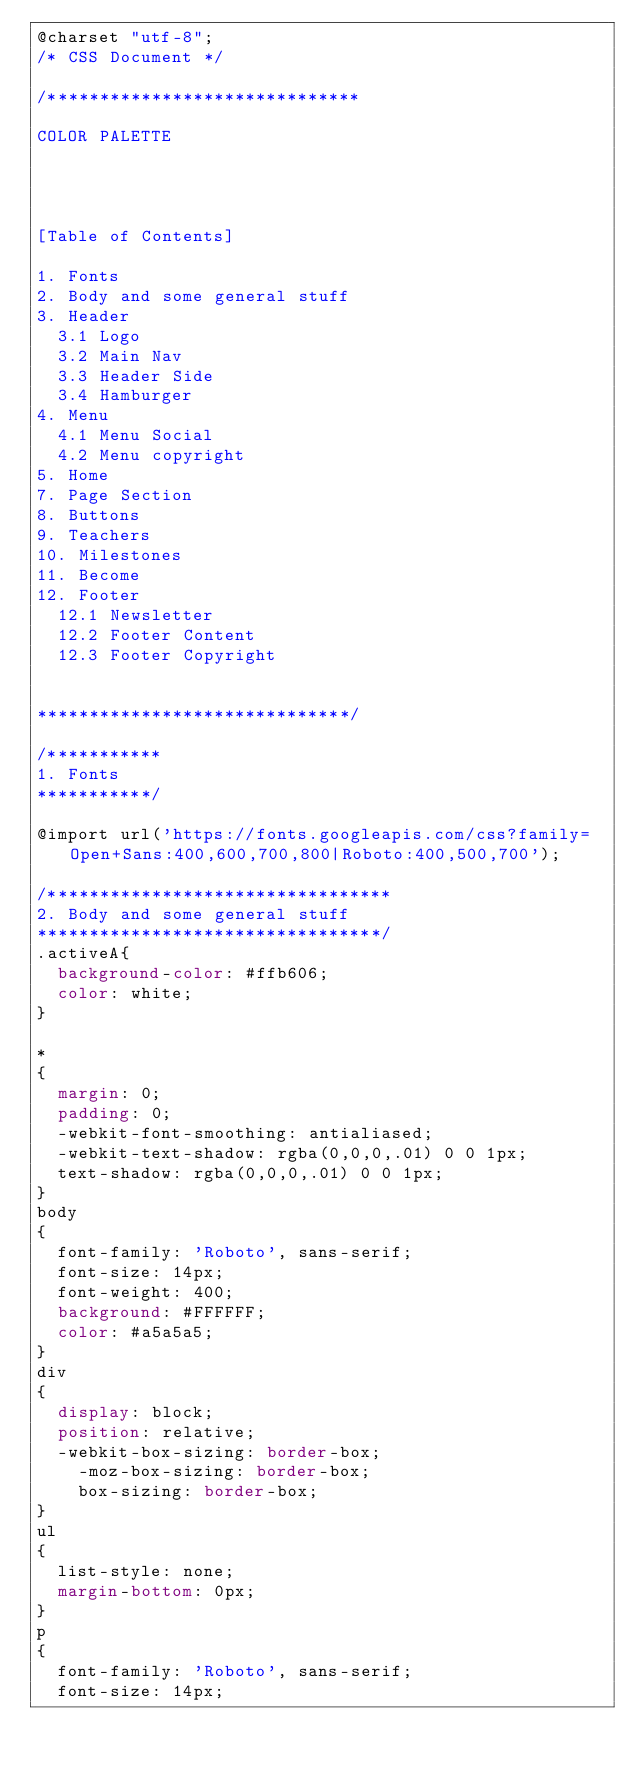Convert code to text. <code><loc_0><loc_0><loc_500><loc_500><_CSS_>@charset "utf-8";
/* CSS Document */

/******************************

COLOR PALETTE




[Table of Contents]

1. Fonts
2. Body and some general stuff
3. Header
	3.1 Logo
	3.2 Main Nav
	3.3 Header Side
	3.4 Hamburger
4. Menu
	4.1 Menu Social
	4.2 Menu copyright
5. Home
7. Page Section
8. Buttons
9. Teachers
10. Milestones
11. Become
12. Footer
	12.1 Newsletter
	12.2 Footer Content
	12.3 Footer Copyright


******************************/

/***********
1. Fonts
***********/

@import url('https://fonts.googleapis.com/css?family=Open+Sans:400,600,700,800|Roboto:400,500,700');

/*********************************
2. Body and some general stuff
*********************************/
.activeA{
	background-color: #ffb606;
	color: white;
}

*
{
	margin: 0;
	padding: 0;
	-webkit-font-smoothing: antialiased;
	-webkit-text-shadow: rgba(0,0,0,.01) 0 0 1px;
	text-shadow: rgba(0,0,0,.01) 0 0 1px;
}
body
{
	font-family: 'Roboto', sans-serif;
	font-size: 14px;
	font-weight: 400;
	background: #FFFFFF;
	color: #a5a5a5;
}
div
{
	display: block;
	position: relative;
	-webkit-box-sizing: border-box;
    -moz-box-sizing: border-box;
    box-sizing: border-box;
}
ul
{
	list-style: none;
	margin-bottom: 0px;
}
p
{
	font-family: 'Roboto', sans-serif;
	font-size: 14px;</code> 